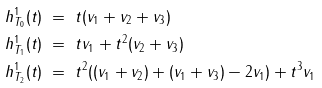Convert formula to latex. <formula><loc_0><loc_0><loc_500><loc_500>h _ { T _ { 0 } } ^ { 1 } ( t ) & \ = \ t ( v _ { 1 } + v _ { 2 } + v _ { 3 } ) \\ h _ { T _ { 1 } } ^ { 1 } ( t ) & \ = \ t v _ { 1 } + t ^ { 2 } ( v _ { 2 } + v _ { 3 } ) \\ h _ { T _ { 2 } } ^ { 1 } ( t ) & \ = \ t ^ { 2 } ( ( v _ { 1 } + v _ { 2 } ) + ( v _ { 1 } + v _ { 3 } ) - 2 v _ { 1 } ) + t ^ { 3 } v _ { 1 }</formula> 